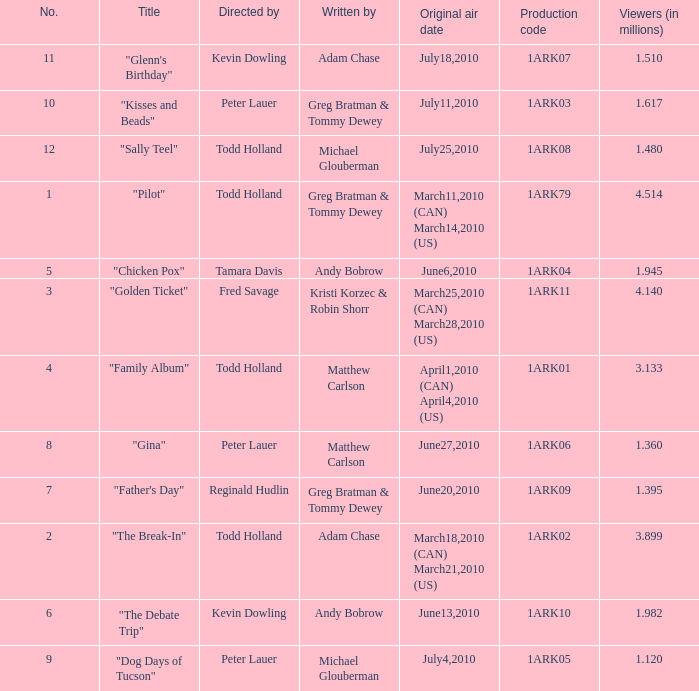List all who wrote for production code 1ark07. Adam Chase. 